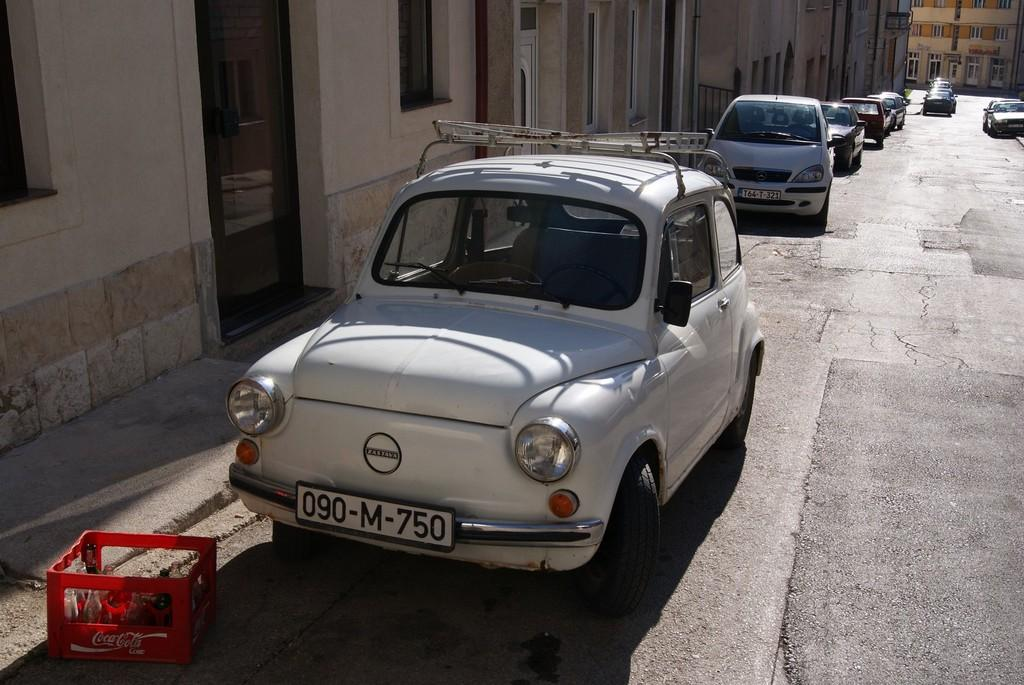Where was the image taken? The image was taken on a road. What can be seen on the road in the image? There are cars parked on the road. What is visible behind the parked cars? There are buildings behind the parked cars. Can you describe the object in the bottom left corner of the image? There is a basket in the bottom left corner of the image. What is inside the basket? There are bottles in the basket. How many cows are grazing on the road in the image? There are no cows present in the image; it is taken on a road with parked cars and buildings. What type of tooth is visible in the image? There is no tooth present in the image. 